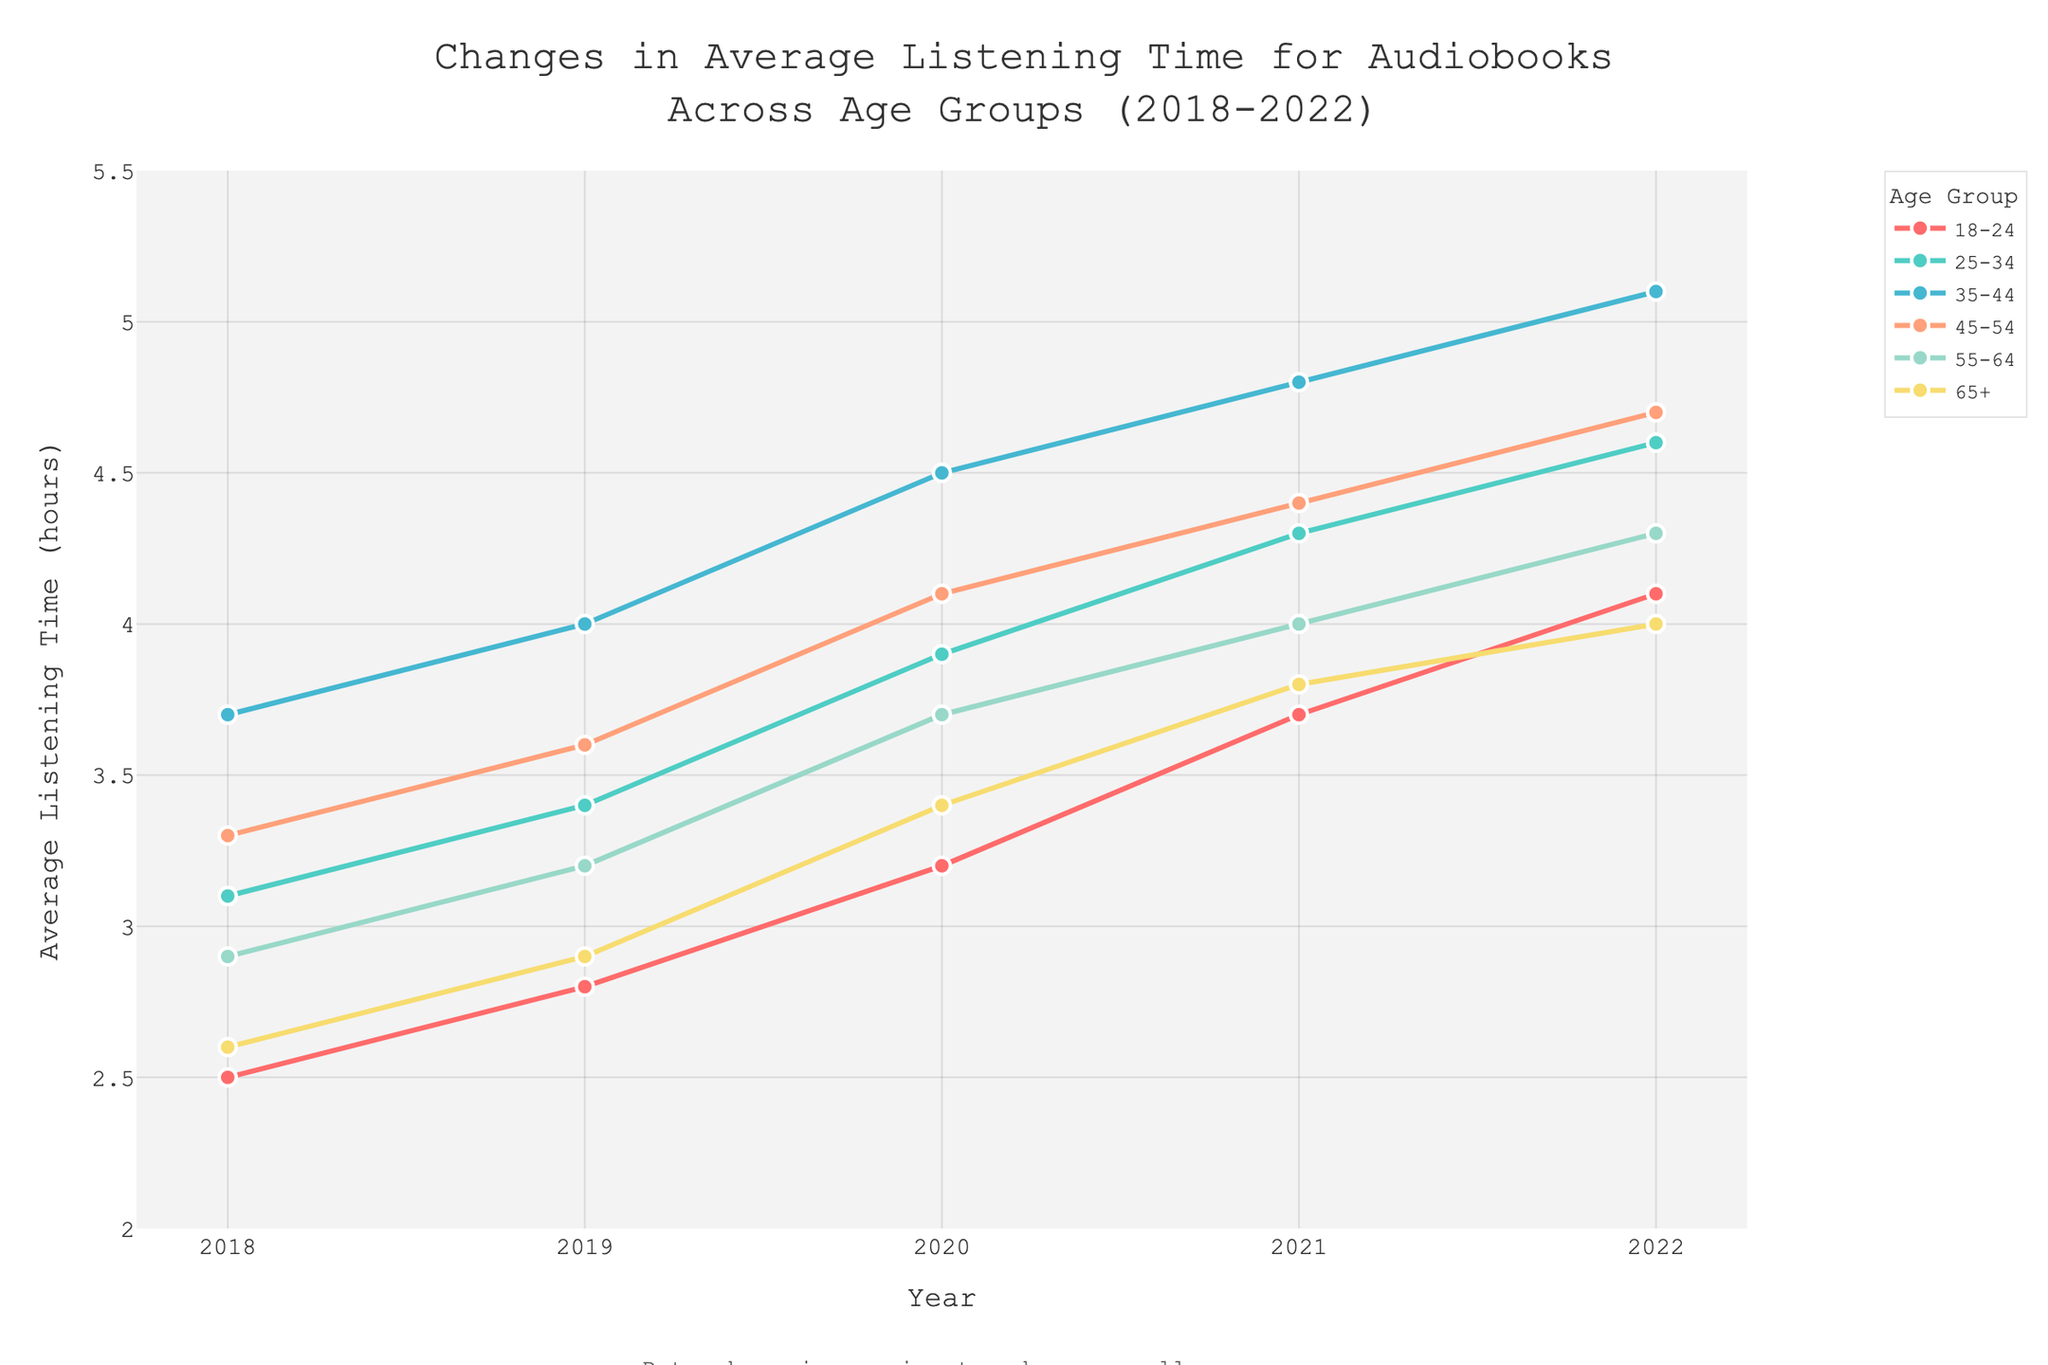What is the overall trend in average listening time for the age group 18-24 from 2018 to 2022? The average listening time for the age group 18-24 increases year by year from 2.5 hours in 2018 to 4.1 hours in 2022, indicating an upward trend.
Answer: Upward trend Which age group had the highest average listening time in 2022? By looking at the graph, the age group 35-44 had the highest average listening time in 2022, with approximately 5.1 hours.
Answer: 35-44 What is the difference in average listening time between the age groups 25-34 and 45-54 in 2020? In 2020, the average listening time for the age group 25-34 was 3.9 hours, and for the age group 45-54, it was 4.1 hours. The difference is 4.1 - 3.9 = 0.2 hours.
Answer: 0.2 hours Which age group showed the greatest increase in average listening time from 2018 to 2022? To find the greatest increase, we look at the difference between 2022 and 2018 for each age group. The age group 18-24 increased from 2.5 to 4.1, a difference of 1.6 hours. The age group 25-34 increased from 3.1 to 4.6, a difference of 1.5 hours. The age group 35-44 increased from 3.7 to 5.1, a difference of 1.4 hours. The age group 45-54 increased from 3.3 to 4.7, a difference of 1.4 hours. The age group 55-64 increased from 2.9 to 4.3, a difference of 1.4 hours. The age group 65+ increased from 2.6 to 4.0, a difference of 1.4 hours. The age group 18-24 showed the greatest increase.
Answer: 18-24 Is there any age group that had a consistent increase in listening time every year? By examining each age group's trend from 2018 to 2022, it is observed that all age groups show a consistent increase in listening time every year.
Answer: Yes, all age groups Compare the average listening time in 2019 and 2022 for the age group 65+. What is the total increase? The average listening time for the age group 65+ was 2.9 hours in 2019 and 4.0 hours in 2022. The total increase is 4.0 - 2.9 = 1.1 hours.
Answer: 1.1 hours In which year did the age group 55-64 surpass an average listening time of 3.5 hours? Observing the plot, in 2020 the age group 55-64 surpassed an average listening time of 3.5 hours, with an average of 3.7 hours.
Answer: 2020 Which age group and year pair shows the smallest average listening time in the provided data? By looking at the entire graph, the age group 18-24 in the year 2018 shows the smallest average listening time, which is 2.5 hours.
Answer: 18-24 in 2018 